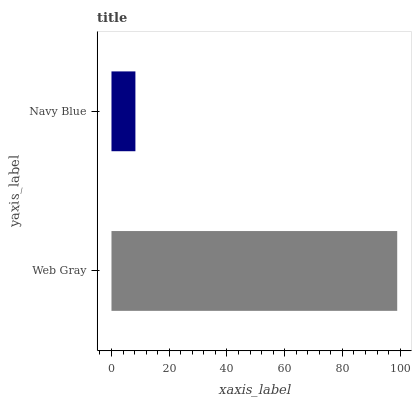Is Navy Blue the minimum?
Answer yes or no. Yes. Is Web Gray the maximum?
Answer yes or no. Yes. Is Navy Blue the maximum?
Answer yes or no. No. Is Web Gray greater than Navy Blue?
Answer yes or no. Yes. Is Navy Blue less than Web Gray?
Answer yes or no. Yes. Is Navy Blue greater than Web Gray?
Answer yes or no. No. Is Web Gray less than Navy Blue?
Answer yes or no. No. Is Web Gray the high median?
Answer yes or no. Yes. Is Navy Blue the low median?
Answer yes or no. Yes. Is Navy Blue the high median?
Answer yes or no. No. Is Web Gray the low median?
Answer yes or no. No. 